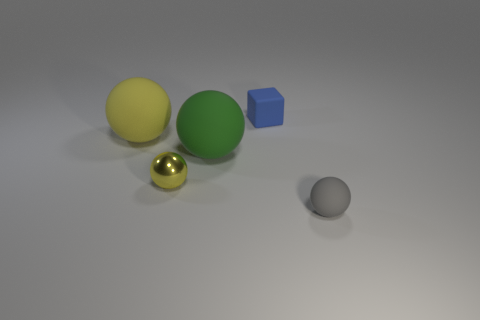Subtract all gray matte spheres. How many spheres are left? 3 Subtract all yellow spheres. How many spheres are left? 2 Subtract all spheres. How many objects are left? 1 Subtract all gray blocks. Subtract all brown balls. How many blocks are left? 1 Subtract all red blocks. How many green balls are left? 1 Subtract all metallic objects. Subtract all small yellow spheres. How many objects are left? 3 Add 1 small gray objects. How many small gray objects are left? 2 Add 1 small yellow metallic balls. How many small yellow metallic balls exist? 2 Add 3 large green balls. How many objects exist? 8 Subtract 0 red spheres. How many objects are left? 5 